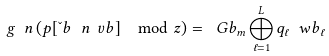Convert formula to latex. <formula><loc_0><loc_0><loc_500><loc_500>g \ n \left ( p [ \L b \ n \ v b ] \mod z \right ) = \ G b _ { m } \bigoplus _ { \ell = 1 } ^ { L } { q _ { \ell } \ w b _ { \ell } }</formula> 